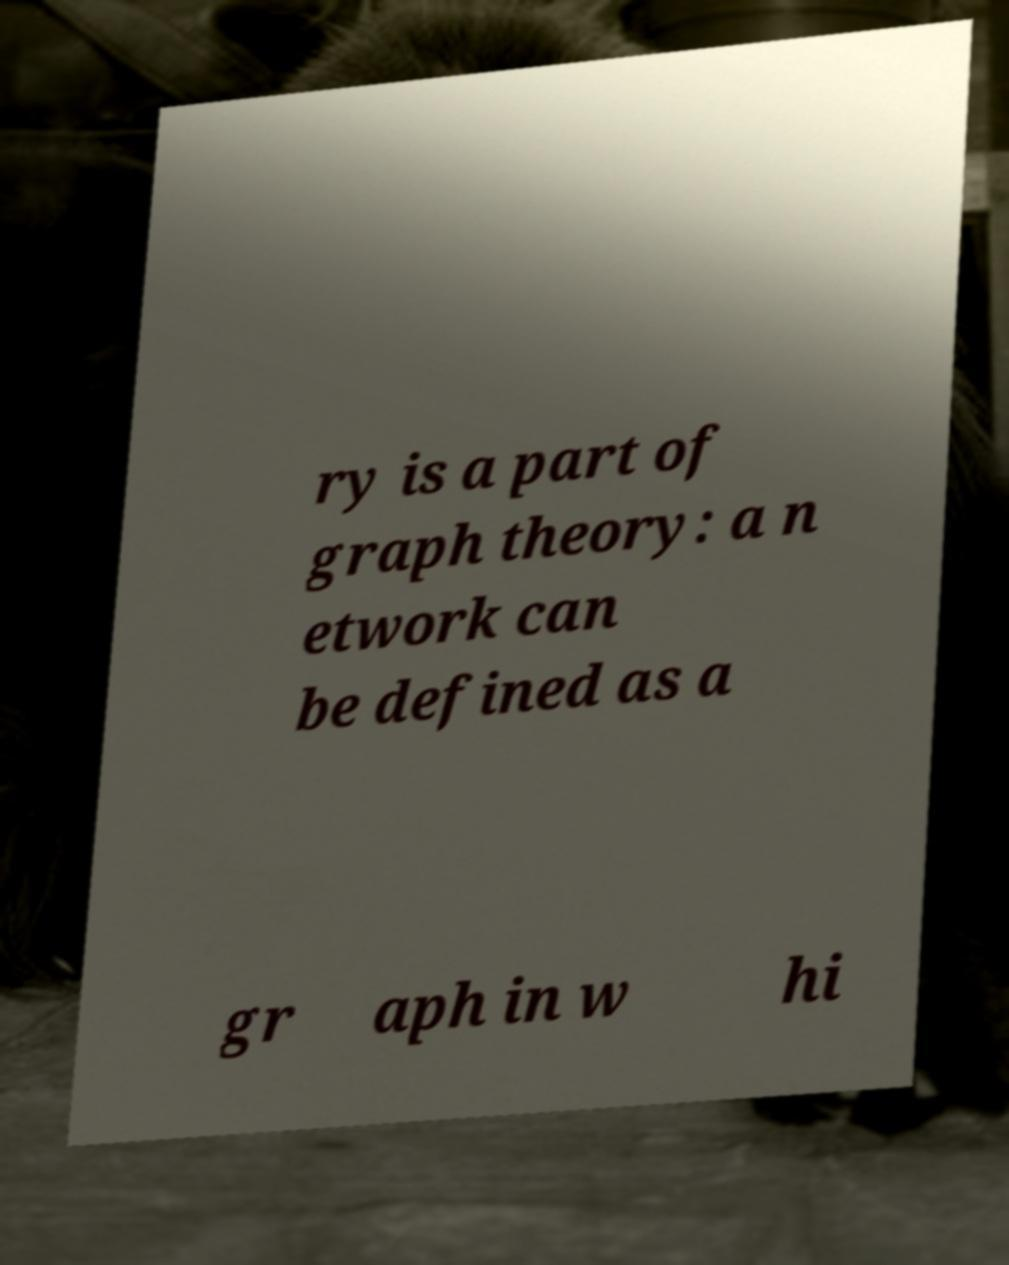Could you assist in decoding the text presented in this image and type it out clearly? ry is a part of graph theory: a n etwork can be defined as a gr aph in w hi 